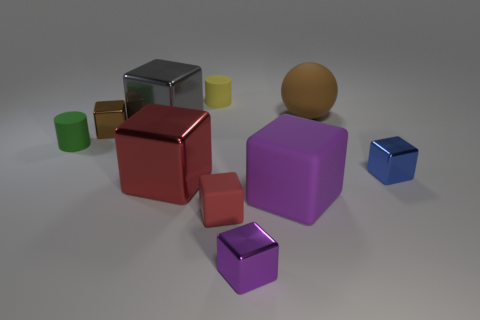Subtract all small brown cubes. How many cubes are left? 6 Subtract all green cylinders. How many red blocks are left? 2 Subtract all red blocks. How many blocks are left? 5 Subtract 3 blocks. How many blocks are left? 4 Subtract all spheres. How many objects are left? 9 Subtract all green cubes. Subtract all red spheres. How many cubes are left? 7 Add 4 big gray cylinders. How many big gray cylinders exist? 4 Subtract 0 purple cylinders. How many objects are left? 10 Subtract all green cylinders. Subtract all large red objects. How many objects are left? 8 Add 3 big matte things. How many big matte things are left? 5 